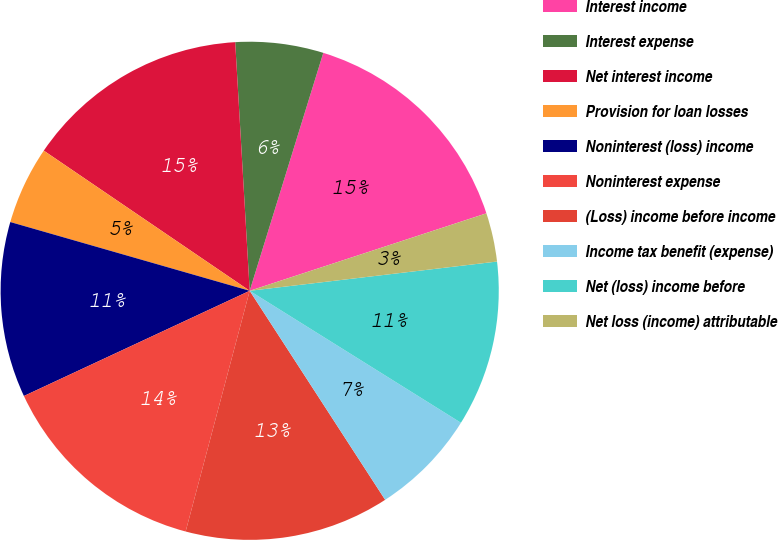Convert chart. <chart><loc_0><loc_0><loc_500><loc_500><pie_chart><fcel>Interest income<fcel>Interest expense<fcel>Net interest income<fcel>Provision for loan losses<fcel>Noninterest (loss) income<fcel>Noninterest expense<fcel>(Loss) income before income<fcel>Income tax benefit (expense)<fcel>Net (loss) income before<fcel>Net loss (income) attributable<nl><fcel>15.19%<fcel>5.7%<fcel>14.56%<fcel>5.06%<fcel>11.39%<fcel>13.92%<fcel>13.29%<fcel>6.96%<fcel>10.76%<fcel>3.16%<nl></chart> 